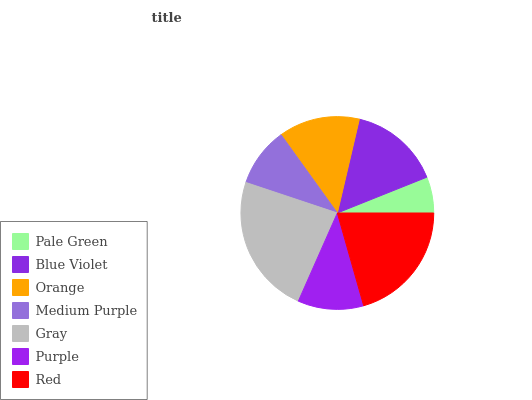Is Pale Green the minimum?
Answer yes or no. Yes. Is Gray the maximum?
Answer yes or no. Yes. Is Blue Violet the minimum?
Answer yes or no. No. Is Blue Violet the maximum?
Answer yes or no. No. Is Blue Violet greater than Pale Green?
Answer yes or no. Yes. Is Pale Green less than Blue Violet?
Answer yes or no. Yes. Is Pale Green greater than Blue Violet?
Answer yes or no. No. Is Blue Violet less than Pale Green?
Answer yes or no. No. Is Orange the high median?
Answer yes or no. Yes. Is Orange the low median?
Answer yes or no. Yes. Is Purple the high median?
Answer yes or no. No. Is Purple the low median?
Answer yes or no. No. 